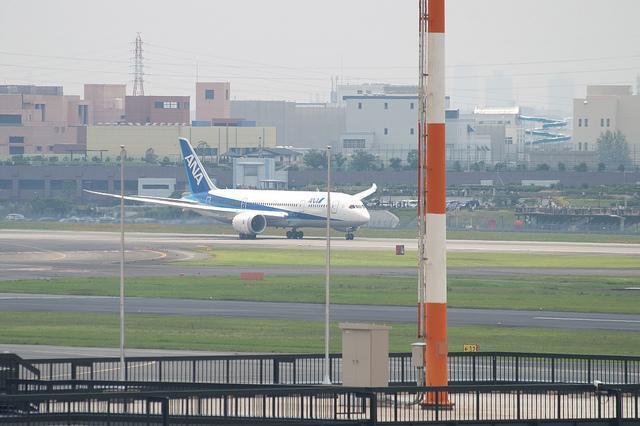How many green kites are in the picture?
Give a very brief answer. 0. 